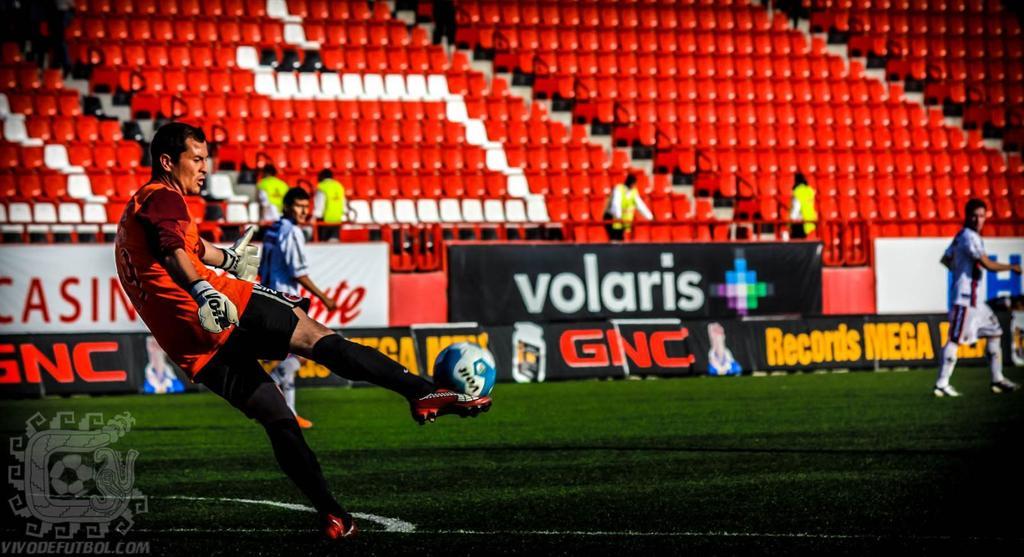What brand of soccer ball are they kicking?
Offer a terse response. Volt. What company is written in red?
Your answer should be compact. Gnc. 